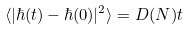Convert formula to latex. <formula><loc_0><loc_0><loc_500><loc_500>\langle | \hbar { ( } t ) - \hbar { ( } 0 ) | ^ { 2 } \rangle = D ( N ) t</formula> 